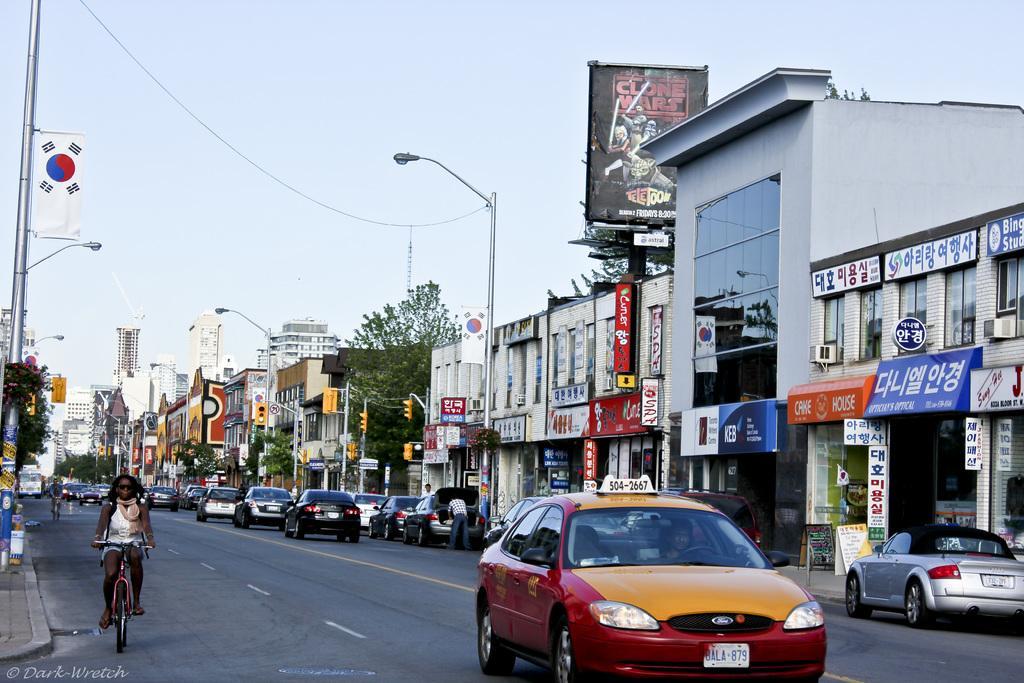Please provide a concise description of this image. In this picture I can see the road in front, on which there are number of cars and few people and on the left side of this picture I can see 2 persons who are on the cycles. In the middle of this picture I can see number of buildings on which there are boards and I see something is written and I can see traffic signals, number of trees, a hoarding, few light poles and a flag on the left side of this image. In the background I can see the sky. 